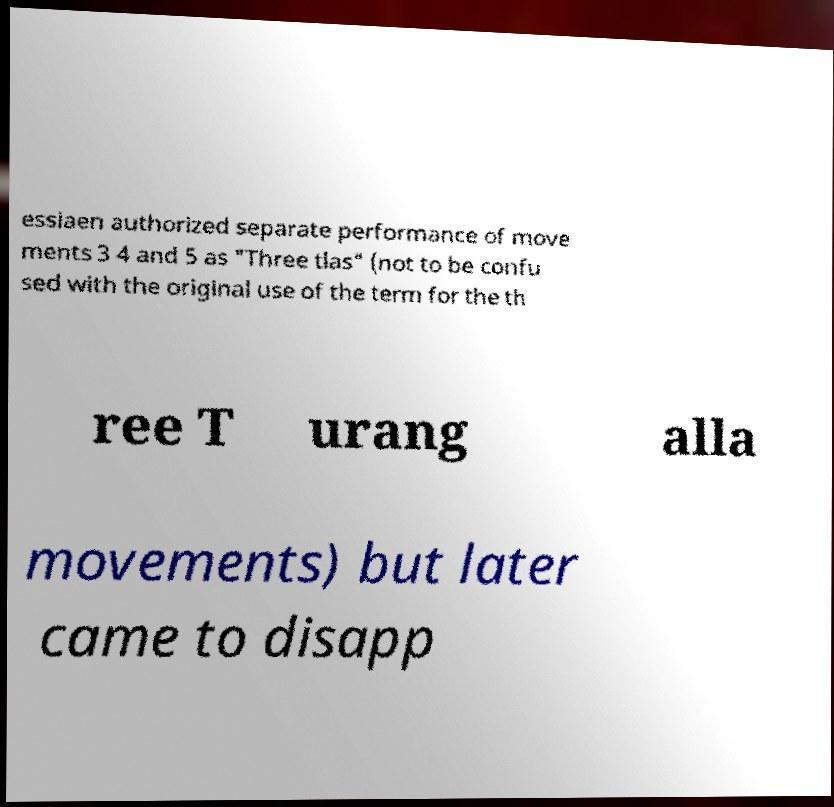There's text embedded in this image that I need extracted. Can you transcribe it verbatim? essiaen authorized separate performance of move ments 3 4 and 5 as "Three tlas" (not to be confu sed with the original use of the term for the th ree T urang alla movements) but later came to disapp 